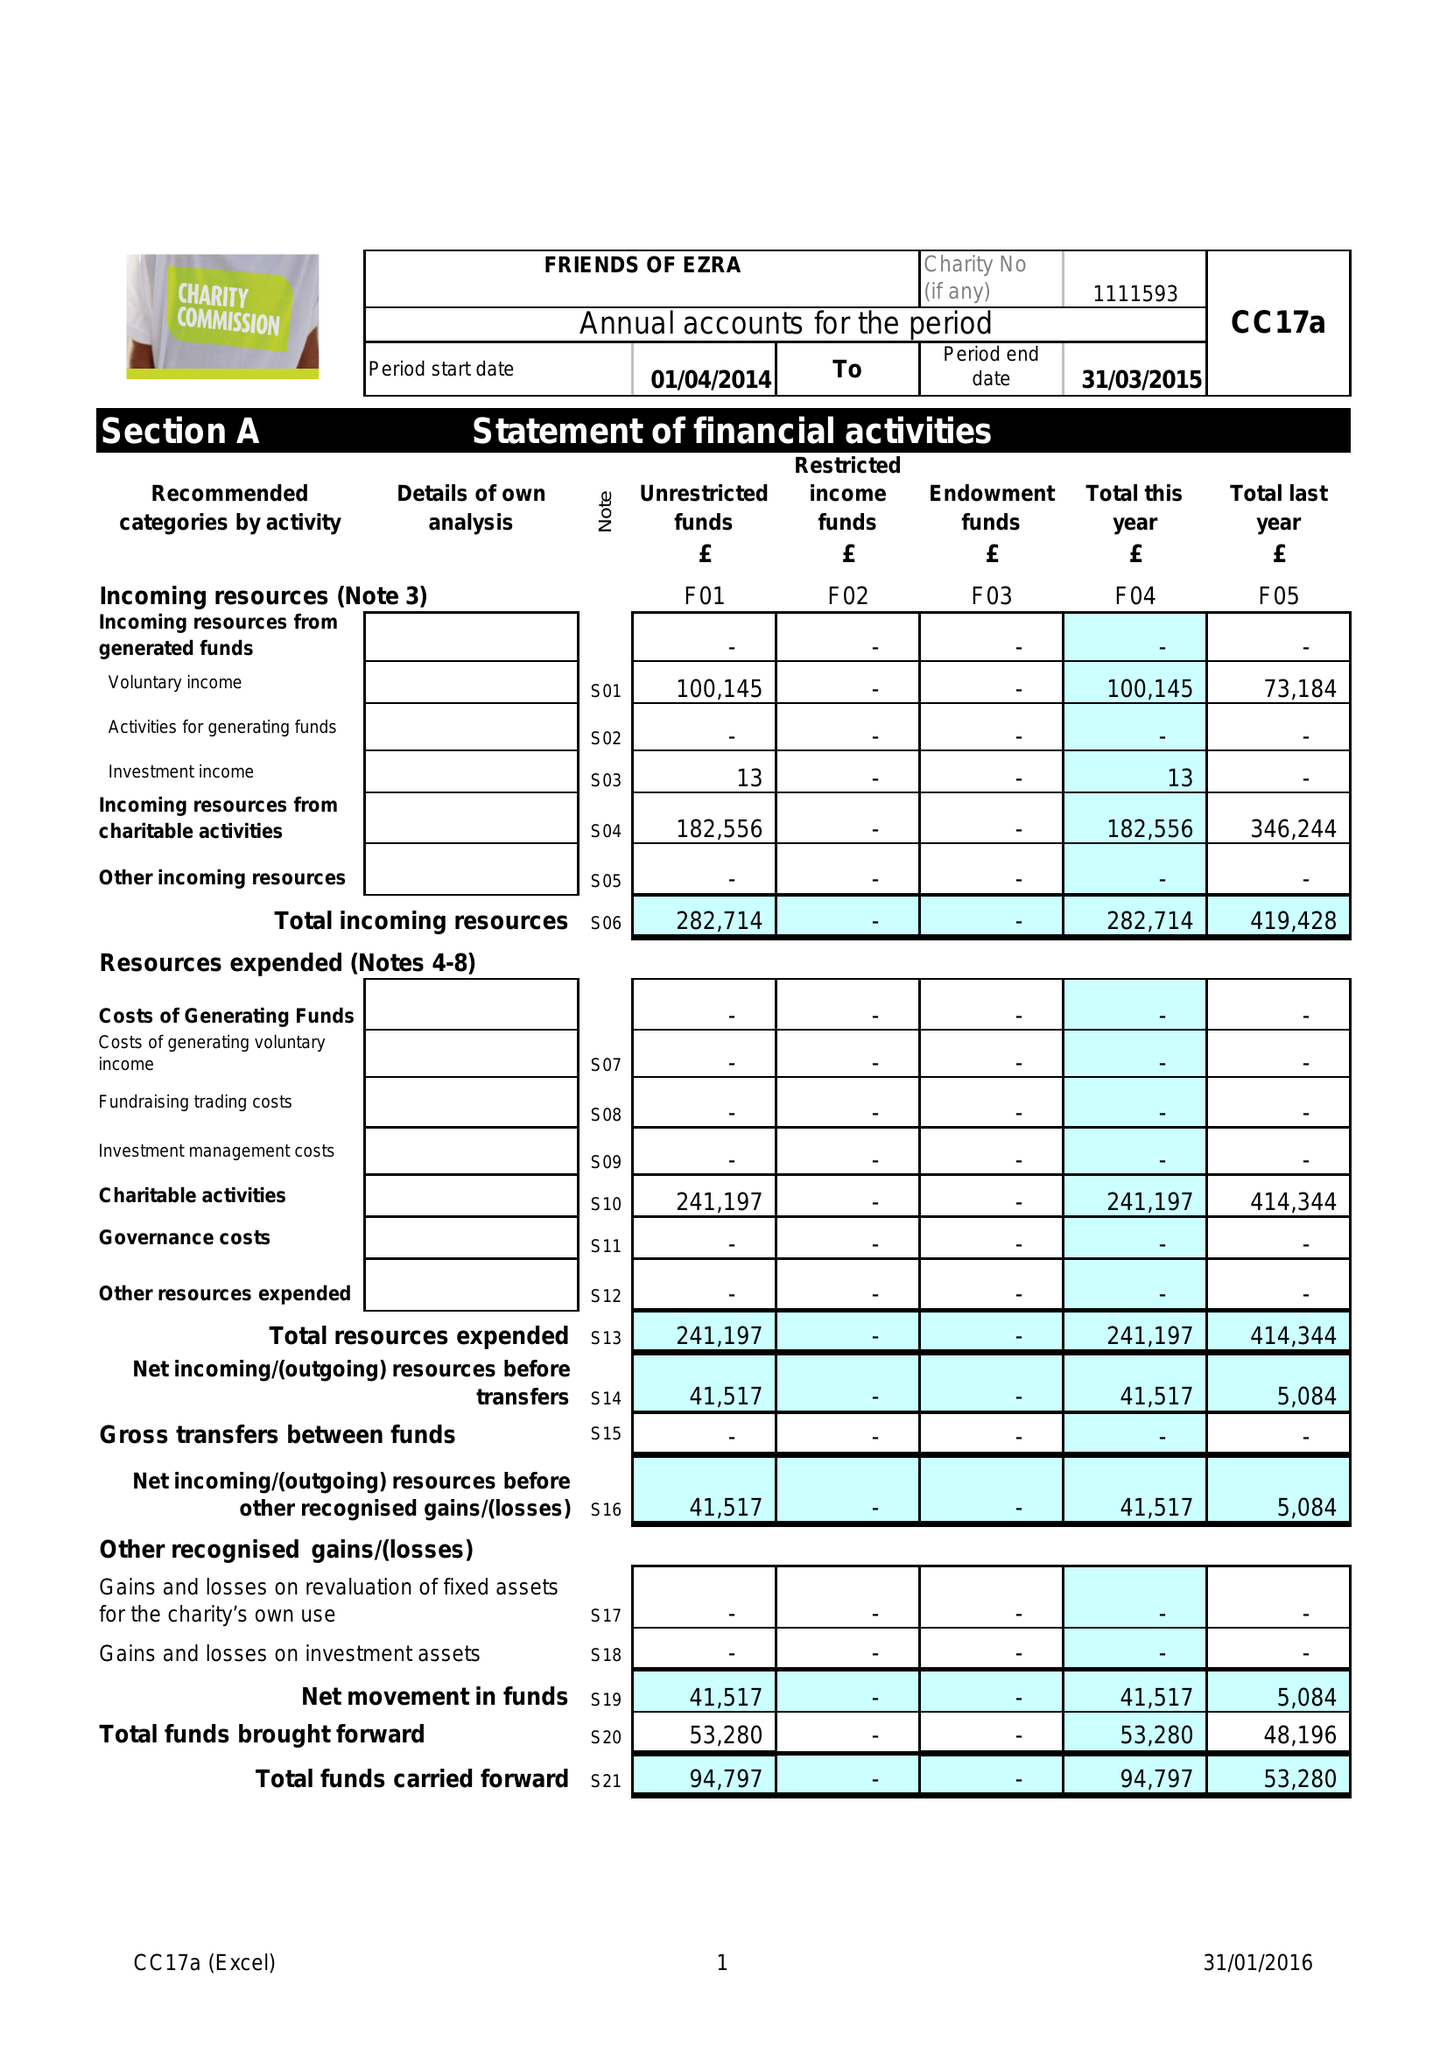What is the value for the address__post_town?
Answer the question using a single word or phrase. LONDON 